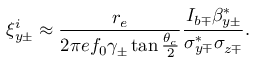<formula> <loc_0><loc_0><loc_500><loc_500>\xi _ { y \pm } ^ { i } \approx \frac { r _ { e } } { 2 \pi e f _ { 0 } \gamma _ { \pm } \tan \frac { \theta _ { c } } { 2 } } \frac { I _ { b \mp } \beta _ { y \pm } ^ { * } } { \sigma _ { y \mp } ^ { * } \sigma _ { z \mp } } .</formula> 